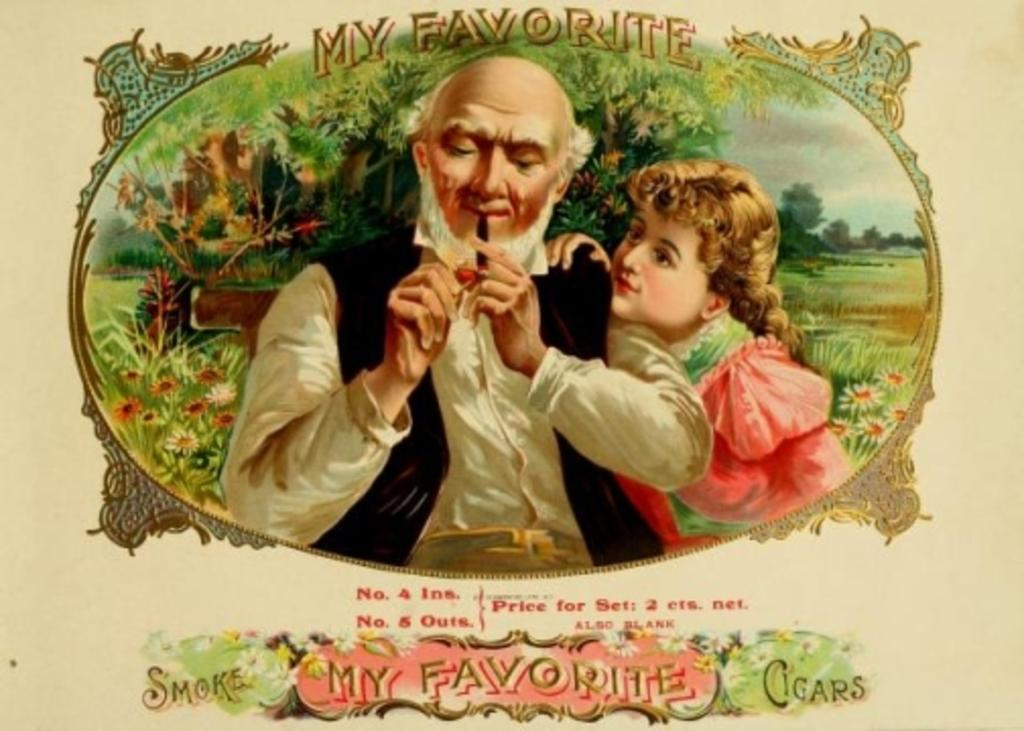<image>
Render a clear and concise summary of the photo. Picture showing a man smoking a pipe and the words "My Favorite" above him. 